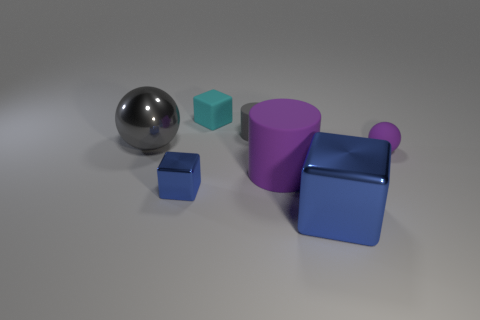Is the number of big rubber cylinders greater than the number of big objects? Based on the image, there is just one big cylinder among the objects presented, and since there are multiple big objects in total, the number of big rubber cylinders is not greater than the number of big objects. 